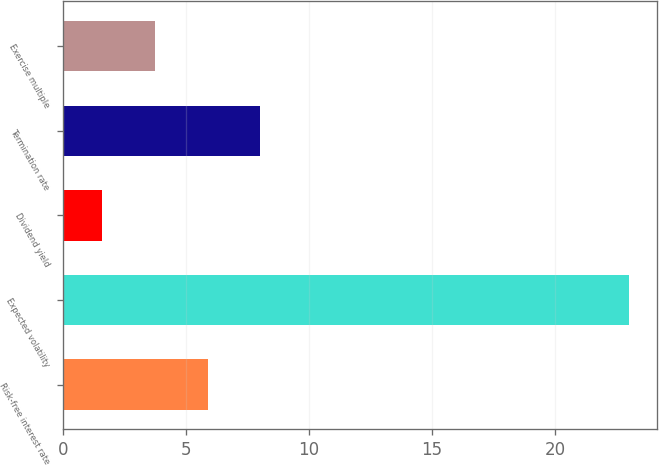Convert chart. <chart><loc_0><loc_0><loc_500><loc_500><bar_chart><fcel>Risk-free interest rate<fcel>Expected volatility<fcel>Dividend yield<fcel>Termination rate<fcel>Exercise multiple<nl><fcel>5.89<fcel>23<fcel>1.61<fcel>8.03<fcel>3.75<nl></chart> 